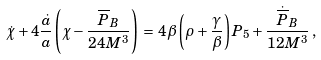<formula> <loc_0><loc_0><loc_500><loc_500>\dot { \chi } + 4 \frac { \dot { a } } { a } \left ( \chi - \frac { \overline { P } _ { B } } { 2 4 M ^ { 3 } } \right ) \, = \, 4 \beta \left ( { \rho + \frac { \gamma } { \beta } } \right ) P _ { 5 } + \frac { { \dot { \overline { P } } _ { B } } } { { 1 2 M ^ { 3 } } } \, ,</formula> 